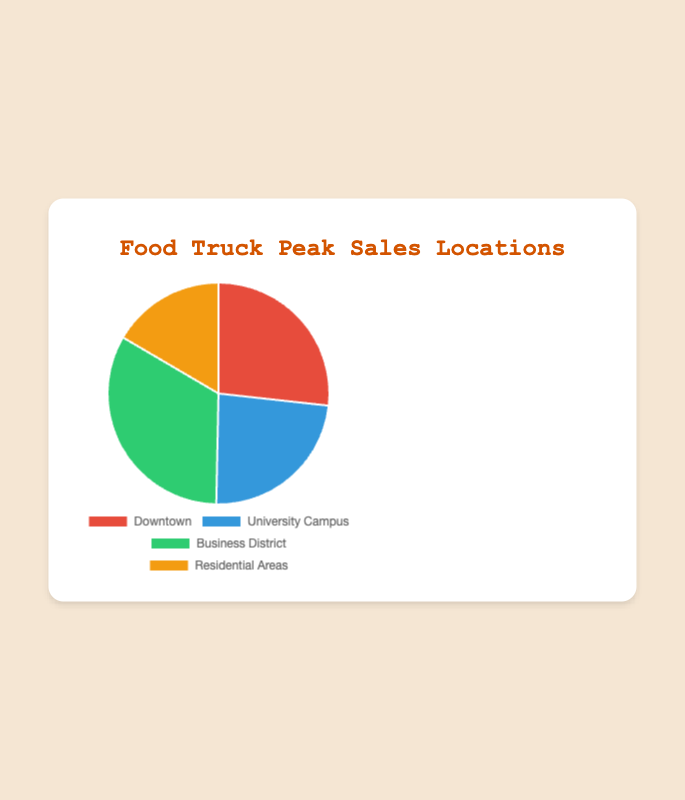What is the total peak sales amount from all locations? Add the peak sales from all locations: 42000 (Downtown) + 37000 (University Campus) + 52000 (Business District) + 26000 (Residential Areas) = 157000
Answer: 157000 Which location has the highest peak sales? Compare the peak sales values: Downtown (42000), University Campus (37000), Business District (52000), and Residential Areas (26000). The Business District has the highest peak sales of 52000
Answer: Business District Which location has the lowest peak sales? Compare the peak sales values: Downtown (42000), University Campus (37000), Business District (52000), and Residential Areas (26000). The Residential Areas have the lowest peak sales of 26000
Answer: Residential Areas What is the peak sales difference between the highest and lowest locations? Subtract the lowest peak sales (Residential Areas) from the highest peak sales (Business District): 52000 - 26000 = 26000
Answer: 26000 How do the peak sales of the University Campus compare to those of Downtown? Compare the peak sales values of University Campus (37000) and Downtown (42000). Downtown has higher peak sales than University Campus
Answer: Downtown has higher peak sales What is the average peak sales amount across all locations? Add the peak sales from all locations and divide by the number of locations: (42000 + 37000 + 52000 + 26000) / 4 = 157000 / 4 = 39250
Answer: 39250 What percentage of the total sales does the Downtown location represent? Divide Downtown's peak sales by the total peak sales and multiply by 100 to get the percentage: (42000 / 157000) * 100 ≈ 26.75%
Answer: 26.75% By how much do peak sales in the Business District exceed those at the University Campus? Subtract the University Campus peak sales (37000) from the Business District peak sales (52000): 52000 - 37000 = 15000
Answer: 15000 What is the combined peak sales of the Downtown and University Campus locations? Add the peak sales of Downtown and University Campus: 42000 + 37000 = 79000
Answer: 79000 